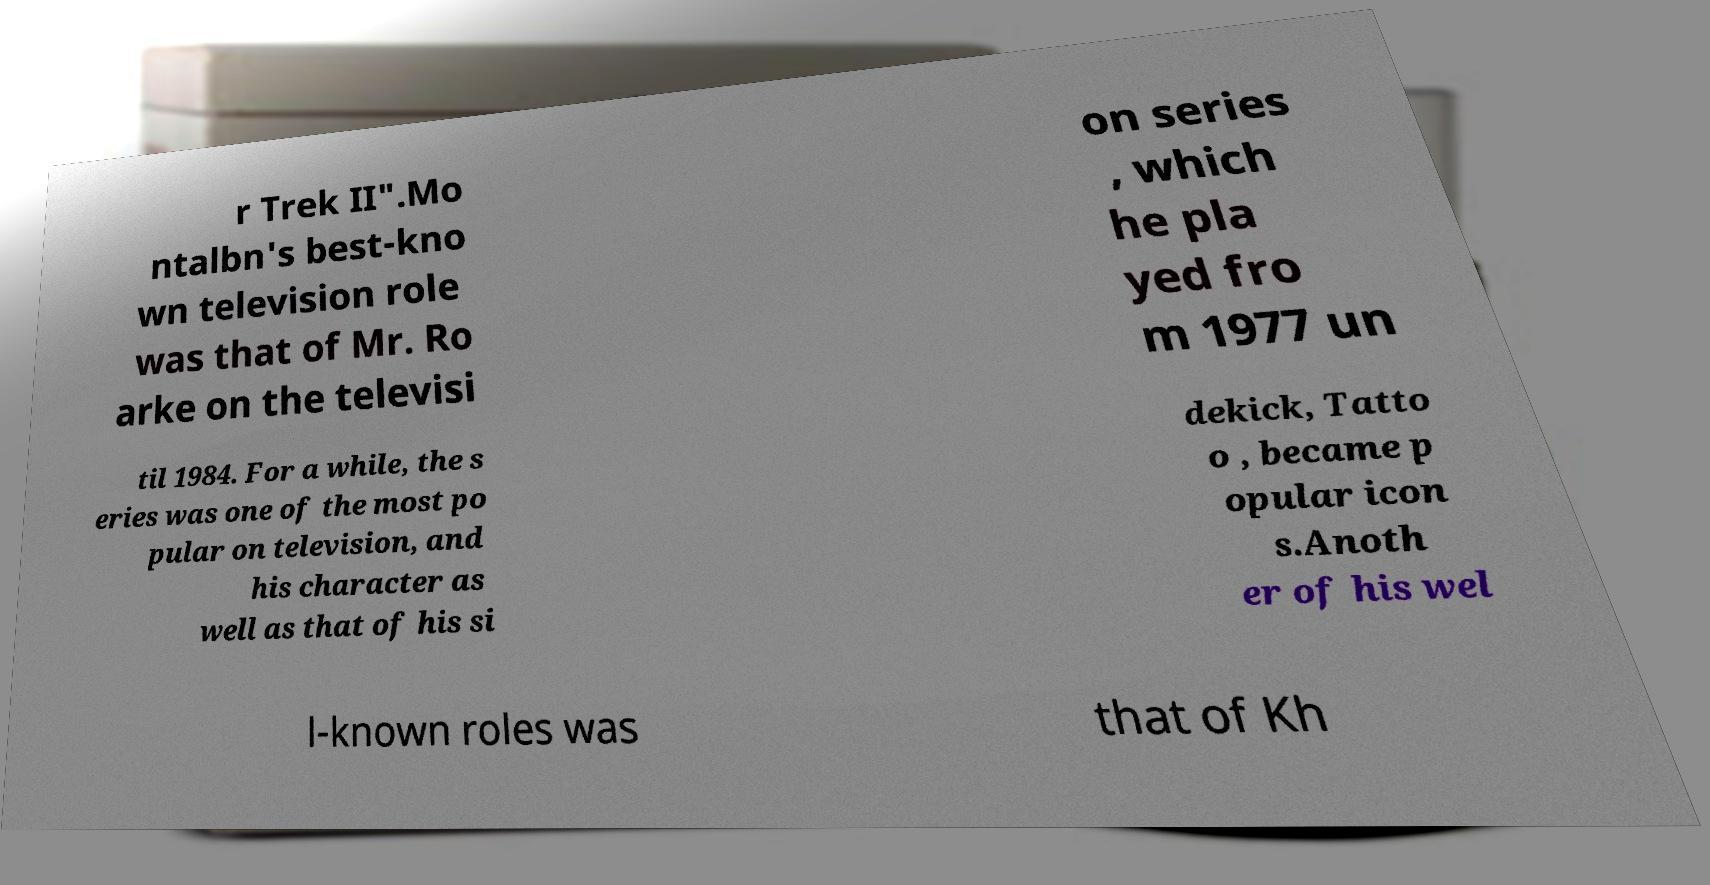I need the written content from this picture converted into text. Can you do that? r Trek II".Mo ntalbn's best-kno wn television role was that of Mr. Ro arke on the televisi on series , which he pla yed fro m 1977 un til 1984. For a while, the s eries was one of the most po pular on television, and his character as well as that of his si dekick, Tatto o , became p opular icon s.Anoth er of his wel l-known roles was that of Kh 